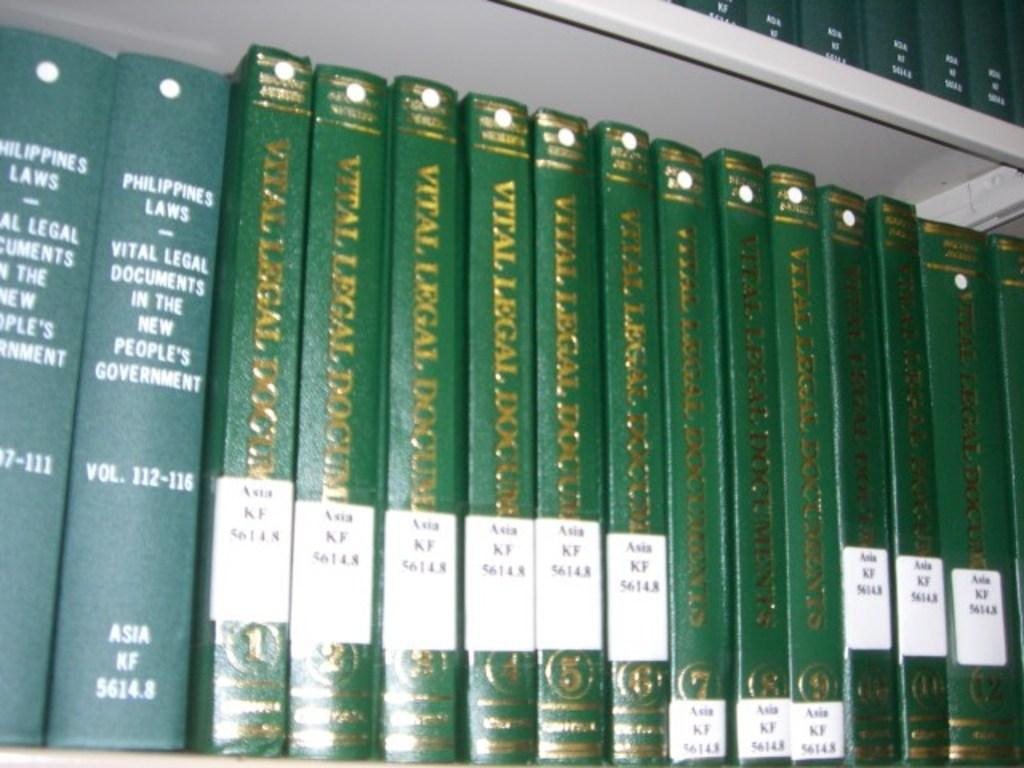<image>
Present a compact description of the photo's key features. A series of Vital Legal Documents sit on a bookshelf. 